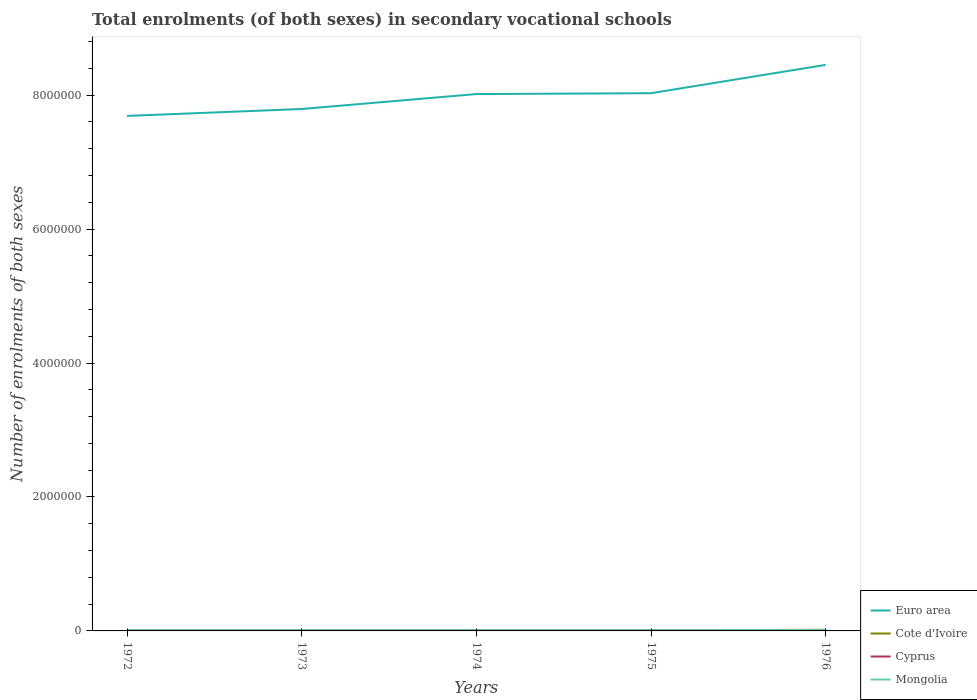Across all years, what is the maximum number of enrolments in secondary schools in Euro area?
Make the answer very short. 7.69e+06. In which year was the number of enrolments in secondary schools in Cyprus maximum?
Give a very brief answer. 1973. What is the total number of enrolments in secondary schools in Euro area in the graph?
Your answer should be very brief. -6.59e+05. What is the difference between the highest and the second highest number of enrolments in secondary schools in Cyprus?
Your answer should be compact. 1914. What is the difference between the highest and the lowest number of enrolments in secondary schools in Euro area?
Give a very brief answer. 3. What is the difference between two consecutive major ticks on the Y-axis?
Your response must be concise. 2.00e+06. Does the graph contain grids?
Your response must be concise. No. Where does the legend appear in the graph?
Your answer should be compact. Bottom right. How many legend labels are there?
Keep it short and to the point. 4. How are the legend labels stacked?
Offer a very short reply. Vertical. What is the title of the graph?
Your response must be concise. Total enrolments (of both sexes) in secondary vocational schools. What is the label or title of the X-axis?
Keep it short and to the point. Years. What is the label or title of the Y-axis?
Make the answer very short. Number of enrolments of both sexes. What is the Number of enrolments of both sexes in Euro area in 1972?
Provide a short and direct response. 7.69e+06. What is the Number of enrolments of both sexes of Cote d'Ivoire in 1972?
Your answer should be very brief. 7297. What is the Number of enrolments of both sexes of Cyprus in 1972?
Provide a succinct answer. 4702. What is the Number of enrolments of both sexes in Mongolia in 1972?
Your answer should be compact. 1.13e+04. What is the Number of enrolments of both sexes of Euro area in 1973?
Ensure brevity in your answer.  7.79e+06. What is the Number of enrolments of both sexes of Cote d'Ivoire in 1973?
Ensure brevity in your answer.  8645. What is the Number of enrolments of both sexes of Cyprus in 1973?
Provide a succinct answer. 4198. What is the Number of enrolments of both sexes of Mongolia in 1973?
Give a very brief answer. 1.15e+04. What is the Number of enrolments of both sexes of Euro area in 1974?
Provide a succinct answer. 8.02e+06. What is the Number of enrolments of both sexes in Cote d'Ivoire in 1974?
Give a very brief answer. 7729. What is the Number of enrolments of both sexes of Cyprus in 1974?
Provide a short and direct response. 4672. What is the Number of enrolments of both sexes in Mongolia in 1974?
Keep it short and to the point. 1.16e+04. What is the Number of enrolments of both sexes in Euro area in 1975?
Provide a short and direct response. 8.03e+06. What is the Number of enrolments of both sexes in Cote d'Ivoire in 1975?
Ensure brevity in your answer.  9253. What is the Number of enrolments of both sexes of Cyprus in 1975?
Provide a succinct answer. 5763. What is the Number of enrolments of both sexes in Mongolia in 1975?
Provide a succinct answer. 1.18e+04. What is the Number of enrolments of both sexes in Euro area in 1976?
Offer a terse response. 8.45e+06. What is the Number of enrolments of both sexes in Cote d'Ivoire in 1976?
Provide a short and direct response. 1.71e+04. What is the Number of enrolments of both sexes of Cyprus in 1976?
Your answer should be compact. 6112. What is the Number of enrolments of both sexes of Mongolia in 1976?
Your answer should be very brief. 1.26e+04. Across all years, what is the maximum Number of enrolments of both sexes of Euro area?
Provide a succinct answer. 8.45e+06. Across all years, what is the maximum Number of enrolments of both sexes in Cote d'Ivoire?
Offer a terse response. 1.71e+04. Across all years, what is the maximum Number of enrolments of both sexes of Cyprus?
Offer a very short reply. 6112. Across all years, what is the maximum Number of enrolments of both sexes in Mongolia?
Give a very brief answer. 1.26e+04. Across all years, what is the minimum Number of enrolments of both sexes of Euro area?
Your answer should be very brief. 7.69e+06. Across all years, what is the minimum Number of enrolments of both sexes in Cote d'Ivoire?
Provide a short and direct response. 7297. Across all years, what is the minimum Number of enrolments of both sexes of Cyprus?
Provide a succinct answer. 4198. Across all years, what is the minimum Number of enrolments of both sexes of Mongolia?
Make the answer very short. 1.13e+04. What is the total Number of enrolments of both sexes in Euro area in the graph?
Give a very brief answer. 4.00e+07. What is the total Number of enrolments of both sexes of Cote d'Ivoire in the graph?
Provide a short and direct response. 5.00e+04. What is the total Number of enrolments of both sexes in Cyprus in the graph?
Offer a very short reply. 2.54e+04. What is the total Number of enrolments of both sexes of Mongolia in the graph?
Your response must be concise. 5.87e+04. What is the difference between the Number of enrolments of both sexes in Euro area in 1972 and that in 1973?
Offer a very short reply. -1.03e+05. What is the difference between the Number of enrolments of both sexes of Cote d'Ivoire in 1972 and that in 1973?
Make the answer very short. -1348. What is the difference between the Number of enrolments of both sexes in Cyprus in 1972 and that in 1973?
Offer a terse response. 504. What is the difference between the Number of enrolments of both sexes of Mongolia in 1972 and that in 1973?
Make the answer very short. -238. What is the difference between the Number of enrolments of both sexes of Euro area in 1972 and that in 1974?
Keep it short and to the point. -3.26e+05. What is the difference between the Number of enrolments of both sexes in Cote d'Ivoire in 1972 and that in 1974?
Provide a succinct answer. -432. What is the difference between the Number of enrolments of both sexes of Cyprus in 1972 and that in 1974?
Offer a terse response. 30. What is the difference between the Number of enrolments of both sexes in Mongolia in 1972 and that in 1974?
Give a very brief answer. -347. What is the difference between the Number of enrolments of both sexes in Euro area in 1972 and that in 1975?
Make the answer very short. -3.39e+05. What is the difference between the Number of enrolments of both sexes of Cote d'Ivoire in 1972 and that in 1975?
Your response must be concise. -1956. What is the difference between the Number of enrolments of both sexes of Cyprus in 1972 and that in 1975?
Your response must be concise. -1061. What is the difference between the Number of enrolments of both sexes of Mongolia in 1972 and that in 1975?
Provide a succinct answer. -535. What is the difference between the Number of enrolments of both sexes of Euro area in 1972 and that in 1976?
Keep it short and to the point. -7.62e+05. What is the difference between the Number of enrolments of both sexes of Cote d'Ivoire in 1972 and that in 1976?
Your response must be concise. -9798. What is the difference between the Number of enrolments of both sexes of Cyprus in 1972 and that in 1976?
Provide a succinct answer. -1410. What is the difference between the Number of enrolments of both sexes in Mongolia in 1972 and that in 1976?
Provide a succinct answer. -1287. What is the difference between the Number of enrolments of both sexes of Euro area in 1973 and that in 1974?
Make the answer very short. -2.23e+05. What is the difference between the Number of enrolments of both sexes of Cote d'Ivoire in 1973 and that in 1974?
Give a very brief answer. 916. What is the difference between the Number of enrolments of both sexes in Cyprus in 1973 and that in 1974?
Provide a short and direct response. -474. What is the difference between the Number of enrolments of both sexes in Mongolia in 1973 and that in 1974?
Ensure brevity in your answer.  -109. What is the difference between the Number of enrolments of both sexes of Euro area in 1973 and that in 1975?
Offer a terse response. -2.36e+05. What is the difference between the Number of enrolments of both sexes in Cote d'Ivoire in 1973 and that in 1975?
Provide a short and direct response. -608. What is the difference between the Number of enrolments of both sexes of Cyprus in 1973 and that in 1975?
Offer a terse response. -1565. What is the difference between the Number of enrolments of both sexes in Mongolia in 1973 and that in 1975?
Keep it short and to the point. -297. What is the difference between the Number of enrolments of both sexes of Euro area in 1973 and that in 1976?
Keep it short and to the point. -6.59e+05. What is the difference between the Number of enrolments of both sexes in Cote d'Ivoire in 1973 and that in 1976?
Ensure brevity in your answer.  -8450. What is the difference between the Number of enrolments of both sexes of Cyprus in 1973 and that in 1976?
Ensure brevity in your answer.  -1914. What is the difference between the Number of enrolments of both sexes in Mongolia in 1973 and that in 1976?
Offer a terse response. -1049. What is the difference between the Number of enrolments of both sexes in Euro area in 1974 and that in 1975?
Ensure brevity in your answer.  -1.26e+04. What is the difference between the Number of enrolments of both sexes in Cote d'Ivoire in 1974 and that in 1975?
Keep it short and to the point. -1524. What is the difference between the Number of enrolments of both sexes of Cyprus in 1974 and that in 1975?
Offer a terse response. -1091. What is the difference between the Number of enrolments of both sexes of Mongolia in 1974 and that in 1975?
Offer a terse response. -188. What is the difference between the Number of enrolments of both sexes of Euro area in 1974 and that in 1976?
Provide a succinct answer. -4.36e+05. What is the difference between the Number of enrolments of both sexes of Cote d'Ivoire in 1974 and that in 1976?
Provide a short and direct response. -9366. What is the difference between the Number of enrolments of both sexes of Cyprus in 1974 and that in 1976?
Provide a short and direct response. -1440. What is the difference between the Number of enrolments of both sexes of Mongolia in 1974 and that in 1976?
Ensure brevity in your answer.  -940. What is the difference between the Number of enrolments of both sexes in Euro area in 1975 and that in 1976?
Ensure brevity in your answer.  -4.23e+05. What is the difference between the Number of enrolments of both sexes of Cote d'Ivoire in 1975 and that in 1976?
Offer a terse response. -7842. What is the difference between the Number of enrolments of both sexes in Cyprus in 1975 and that in 1976?
Give a very brief answer. -349. What is the difference between the Number of enrolments of both sexes in Mongolia in 1975 and that in 1976?
Offer a very short reply. -752. What is the difference between the Number of enrolments of both sexes of Euro area in 1972 and the Number of enrolments of both sexes of Cote d'Ivoire in 1973?
Your answer should be very brief. 7.68e+06. What is the difference between the Number of enrolments of both sexes of Euro area in 1972 and the Number of enrolments of both sexes of Cyprus in 1973?
Provide a short and direct response. 7.69e+06. What is the difference between the Number of enrolments of both sexes in Euro area in 1972 and the Number of enrolments of both sexes in Mongolia in 1973?
Offer a terse response. 7.68e+06. What is the difference between the Number of enrolments of both sexes of Cote d'Ivoire in 1972 and the Number of enrolments of both sexes of Cyprus in 1973?
Your response must be concise. 3099. What is the difference between the Number of enrolments of both sexes in Cote d'Ivoire in 1972 and the Number of enrolments of both sexes in Mongolia in 1973?
Ensure brevity in your answer.  -4208. What is the difference between the Number of enrolments of both sexes in Cyprus in 1972 and the Number of enrolments of both sexes in Mongolia in 1973?
Your answer should be very brief. -6803. What is the difference between the Number of enrolments of both sexes in Euro area in 1972 and the Number of enrolments of both sexes in Cote d'Ivoire in 1974?
Provide a short and direct response. 7.68e+06. What is the difference between the Number of enrolments of both sexes in Euro area in 1972 and the Number of enrolments of both sexes in Cyprus in 1974?
Provide a short and direct response. 7.69e+06. What is the difference between the Number of enrolments of both sexes of Euro area in 1972 and the Number of enrolments of both sexes of Mongolia in 1974?
Your response must be concise. 7.68e+06. What is the difference between the Number of enrolments of both sexes of Cote d'Ivoire in 1972 and the Number of enrolments of both sexes of Cyprus in 1974?
Your answer should be compact. 2625. What is the difference between the Number of enrolments of both sexes in Cote d'Ivoire in 1972 and the Number of enrolments of both sexes in Mongolia in 1974?
Give a very brief answer. -4317. What is the difference between the Number of enrolments of both sexes of Cyprus in 1972 and the Number of enrolments of both sexes of Mongolia in 1974?
Offer a very short reply. -6912. What is the difference between the Number of enrolments of both sexes of Euro area in 1972 and the Number of enrolments of both sexes of Cote d'Ivoire in 1975?
Your response must be concise. 7.68e+06. What is the difference between the Number of enrolments of both sexes in Euro area in 1972 and the Number of enrolments of both sexes in Cyprus in 1975?
Ensure brevity in your answer.  7.68e+06. What is the difference between the Number of enrolments of both sexes in Euro area in 1972 and the Number of enrolments of both sexes in Mongolia in 1975?
Offer a terse response. 7.68e+06. What is the difference between the Number of enrolments of both sexes in Cote d'Ivoire in 1972 and the Number of enrolments of both sexes in Cyprus in 1975?
Make the answer very short. 1534. What is the difference between the Number of enrolments of both sexes in Cote d'Ivoire in 1972 and the Number of enrolments of both sexes in Mongolia in 1975?
Offer a very short reply. -4505. What is the difference between the Number of enrolments of both sexes of Cyprus in 1972 and the Number of enrolments of both sexes of Mongolia in 1975?
Your response must be concise. -7100. What is the difference between the Number of enrolments of both sexes in Euro area in 1972 and the Number of enrolments of both sexes in Cote d'Ivoire in 1976?
Provide a succinct answer. 7.67e+06. What is the difference between the Number of enrolments of both sexes in Euro area in 1972 and the Number of enrolments of both sexes in Cyprus in 1976?
Your answer should be very brief. 7.68e+06. What is the difference between the Number of enrolments of both sexes in Euro area in 1972 and the Number of enrolments of both sexes in Mongolia in 1976?
Your answer should be very brief. 7.68e+06. What is the difference between the Number of enrolments of both sexes in Cote d'Ivoire in 1972 and the Number of enrolments of both sexes in Cyprus in 1976?
Your answer should be compact. 1185. What is the difference between the Number of enrolments of both sexes of Cote d'Ivoire in 1972 and the Number of enrolments of both sexes of Mongolia in 1976?
Your answer should be compact. -5257. What is the difference between the Number of enrolments of both sexes in Cyprus in 1972 and the Number of enrolments of both sexes in Mongolia in 1976?
Your answer should be very brief. -7852. What is the difference between the Number of enrolments of both sexes of Euro area in 1973 and the Number of enrolments of both sexes of Cote d'Ivoire in 1974?
Provide a short and direct response. 7.79e+06. What is the difference between the Number of enrolments of both sexes of Euro area in 1973 and the Number of enrolments of both sexes of Cyprus in 1974?
Provide a short and direct response. 7.79e+06. What is the difference between the Number of enrolments of both sexes of Euro area in 1973 and the Number of enrolments of both sexes of Mongolia in 1974?
Your answer should be very brief. 7.78e+06. What is the difference between the Number of enrolments of both sexes in Cote d'Ivoire in 1973 and the Number of enrolments of both sexes in Cyprus in 1974?
Provide a succinct answer. 3973. What is the difference between the Number of enrolments of both sexes of Cote d'Ivoire in 1973 and the Number of enrolments of both sexes of Mongolia in 1974?
Provide a short and direct response. -2969. What is the difference between the Number of enrolments of both sexes of Cyprus in 1973 and the Number of enrolments of both sexes of Mongolia in 1974?
Make the answer very short. -7416. What is the difference between the Number of enrolments of both sexes in Euro area in 1973 and the Number of enrolments of both sexes in Cote d'Ivoire in 1975?
Offer a terse response. 7.78e+06. What is the difference between the Number of enrolments of both sexes in Euro area in 1973 and the Number of enrolments of both sexes in Cyprus in 1975?
Make the answer very short. 7.79e+06. What is the difference between the Number of enrolments of both sexes in Euro area in 1973 and the Number of enrolments of both sexes in Mongolia in 1975?
Ensure brevity in your answer.  7.78e+06. What is the difference between the Number of enrolments of both sexes of Cote d'Ivoire in 1973 and the Number of enrolments of both sexes of Cyprus in 1975?
Offer a very short reply. 2882. What is the difference between the Number of enrolments of both sexes of Cote d'Ivoire in 1973 and the Number of enrolments of both sexes of Mongolia in 1975?
Offer a terse response. -3157. What is the difference between the Number of enrolments of both sexes of Cyprus in 1973 and the Number of enrolments of both sexes of Mongolia in 1975?
Your answer should be very brief. -7604. What is the difference between the Number of enrolments of both sexes of Euro area in 1973 and the Number of enrolments of both sexes of Cote d'Ivoire in 1976?
Ensure brevity in your answer.  7.78e+06. What is the difference between the Number of enrolments of both sexes in Euro area in 1973 and the Number of enrolments of both sexes in Cyprus in 1976?
Provide a succinct answer. 7.79e+06. What is the difference between the Number of enrolments of both sexes in Euro area in 1973 and the Number of enrolments of both sexes in Mongolia in 1976?
Your answer should be very brief. 7.78e+06. What is the difference between the Number of enrolments of both sexes of Cote d'Ivoire in 1973 and the Number of enrolments of both sexes of Cyprus in 1976?
Your answer should be compact. 2533. What is the difference between the Number of enrolments of both sexes in Cote d'Ivoire in 1973 and the Number of enrolments of both sexes in Mongolia in 1976?
Your answer should be compact. -3909. What is the difference between the Number of enrolments of both sexes of Cyprus in 1973 and the Number of enrolments of both sexes of Mongolia in 1976?
Provide a succinct answer. -8356. What is the difference between the Number of enrolments of both sexes in Euro area in 1974 and the Number of enrolments of both sexes in Cote d'Ivoire in 1975?
Offer a terse response. 8.01e+06. What is the difference between the Number of enrolments of both sexes in Euro area in 1974 and the Number of enrolments of both sexes in Cyprus in 1975?
Provide a short and direct response. 8.01e+06. What is the difference between the Number of enrolments of both sexes of Euro area in 1974 and the Number of enrolments of both sexes of Mongolia in 1975?
Ensure brevity in your answer.  8.00e+06. What is the difference between the Number of enrolments of both sexes of Cote d'Ivoire in 1974 and the Number of enrolments of both sexes of Cyprus in 1975?
Make the answer very short. 1966. What is the difference between the Number of enrolments of both sexes of Cote d'Ivoire in 1974 and the Number of enrolments of both sexes of Mongolia in 1975?
Offer a very short reply. -4073. What is the difference between the Number of enrolments of both sexes in Cyprus in 1974 and the Number of enrolments of both sexes in Mongolia in 1975?
Your answer should be very brief. -7130. What is the difference between the Number of enrolments of both sexes of Euro area in 1974 and the Number of enrolments of both sexes of Cote d'Ivoire in 1976?
Keep it short and to the point. 8.00e+06. What is the difference between the Number of enrolments of both sexes of Euro area in 1974 and the Number of enrolments of both sexes of Cyprus in 1976?
Give a very brief answer. 8.01e+06. What is the difference between the Number of enrolments of both sexes of Euro area in 1974 and the Number of enrolments of both sexes of Mongolia in 1976?
Your response must be concise. 8.00e+06. What is the difference between the Number of enrolments of both sexes of Cote d'Ivoire in 1974 and the Number of enrolments of both sexes of Cyprus in 1976?
Make the answer very short. 1617. What is the difference between the Number of enrolments of both sexes in Cote d'Ivoire in 1974 and the Number of enrolments of both sexes in Mongolia in 1976?
Offer a terse response. -4825. What is the difference between the Number of enrolments of both sexes in Cyprus in 1974 and the Number of enrolments of both sexes in Mongolia in 1976?
Give a very brief answer. -7882. What is the difference between the Number of enrolments of both sexes of Euro area in 1975 and the Number of enrolments of both sexes of Cote d'Ivoire in 1976?
Give a very brief answer. 8.01e+06. What is the difference between the Number of enrolments of both sexes of Euro area in 1975 and the Number of enrolments of both sexes of Cyprus in 1976?
Offer a very short reply. 8.02e+06. What is the difference between the Number of enrolments of both sexes in Euro area in 1975 and the Number of enrolments of both sexes in Mongolia in 1976?
Offer a very short reply. 8.02e+06. What is the difference between the Number of enrolments of both sexes in Cote d'Ivoire in 1975 and the Number of enrolments of both sexes in Cyprus in 1976?
Give a very brief answer. 3141. What is the difference between the Number of enrolments of both sexes of Cote d'Ivoire in 1975 and the Number of enrolments of both sexes of Mongolia in 1976?
Provide a succinct answer. -3301. What is the difference between the Number of enrolments of both sexes in Cyprus in 1975 and the Number of enrolments of both sexes in Mongolia in 1976?
Offer a very short reply. -6791. What is the average Number of enrolments of both sexes in Euro area per year?
Offer a terse response. 8.00e+06. What is the average Number of enrolments of both sexes in Cote d'Ivoire per year?
Your response must be concise. 1.00e+04. What is the average Number of enrolments of both sexes of Cyprus per year?
Your response must be concise. 5089.4. What is the average Number of enrolments of both sexes of Mongolia per year?
Give a very brief answer. 1.17e+04. In the year 1972, what is the difference between the Number of enrolments of both sexes of Euro area and Number of enrolments of both sexes of Cote d'Ivoire?
Your answer should be very brief. 7.68e+06. In the year 1972, what is the difference between the Number of enrolments of both sexes of Euro area and Number of enrolments of both sexes of Cyprus?
Ensure brevity in your answer.  7.69e+06. In the year 1972, what is the difference between the Number of enrolments of both sexes of Euro area and Number of enrolments of both sexes of Mongolia?
Your answer should be very brief. 7.68e+06. In the year 1972, what is the difference between the Number of enrolments of both sexes of Cote d'Ivoire and Number of enrolments of both sexes of Cyprus?
Your answer should be compact. 2595. In the year 1972, what is the difference between the Number of enrolments of both sexes of Cote d'Ivoire and Number of enrolments of both sexes of Mongolia?
Your answer should be very brief. -3970. In the year 1972, what is the difference between the Number of enrolments of both sexes of Cyprus and Number of enrolments of both sexes of Mongolia?
Give a very brief answer. -6565. In the year 1973, what is the difference between the Number of enrolments of both sexes of Euro area and Number of enrolments of both sexes of Cote d'Ivoire?
Your answer should be compact. 7.78e+06. In the year 1973, what is the difference between the Number of enrolments of both sexes in Euro area and Number of enrolments of both sexes in Cyprus?
Give a very brief answer. 7.79e+06. In the year 1973, what is the difference between the Number of enrolments of both sexes of Euro area and Number of enrolments of both sexes of Mongolia?
Offer a terse response. 7.78e+06. In the year 1973, what is the difference between the Number of enrolments of both sexes of Cote d'Ivoire and Number of enrolments of both sexes of Cyprus?
Your answer should be compact. 4447. In the year 1973, what is the difference between the Number of enrolments of both sexes in Cote d'Ivoire and Number of enrolments of both sexes in Mongolia?
Offer a very short reply. -2860. In the year 1973, what is the difference between the Number of enrolments of both sexes of Cyprus and Number of enrolments of both sexes of Mongolia?
Your answer should be very brief. -7307. In the year 1974, what is the difference between the Number of enrolments of both sexes in Euro area and Number of enrolments of both sexes in Cote d'Ivoire?
Ensure brevity in your answer.  8.01e+06. In the year 1974, what is the difference between the Number of enrolments of both sexes in Euro area and Number of enrolments of both sexes in Cyprus?
Give a very brief answer. 8.01e+06. In the year 1974, what is the difference between the Number of enrolments of both sexes of Euro area and Number of enrolments of both sexes of Mongolia?
Your response must be concise. 8.00e+06. In the year 1974, what is the difference between the Number of enrolments of both sexes in Cote d'Ivoire and Number of enrolments of both sexes in Cyprus?
Your answer should be very brief. 3057. In the year 1974, what is the difference between the Number of enrolments of both sexes in Cote d'Ivoire and Number of enrolments of both sexes in Mongolia?
Offer a very short reply. -3885. In the year 1974, what is the difference between the Number of enrolments of both sexes in Cyprus and Number of enrolments of both sexes in Mongolia?
Make the answer very short. -6942. In the year 1975, what is the difference between the Number of enrolments of both sexes in Euro area and Number of enrolments of both sexes in Cote d'Ivoire?
Provide a succinct answer. 8.02e+06. In the year 1975, what is the difference between the Number of enrolments of both sexes of Euro area and Number of enrolments of both sexes of Cyprus?
Keep it short and to the point. 8.02e+06. In the year 1975, what is the difference between the Number of enrolments of both sexes in Euro area and Number of enrolments of both sexes in Mongolia?
Offer a terse response. 8.02e+06. In the year 1975, what is the difference between the Number of enrolments of both sexes of Cote d'Ivoire and Number of enrolments of both sexes of Cyprus?
Give a very brief answer. 3490. In the year 1975, what is the difference between the Number of enrolments of both sexes of Cote d'Ivoire and Number of enrolments of both sexes of Mongolia?
Offer a very short reply. -2549. In the year 1975, what is the difference between the Number of enrolments of both sexes of Cyprus and Number of enrolments of both sexes of Mongolia?
Keep it short and to the point. -6039. In the year 1976, what is the difference between the Number of enrolments of both sexes of Euro area and Number of enrolments of both sexes of Cote d'Ivoire?
Provide a short and direct response. 8.44e+06. In the year 1976, what is the difference between the Number of enrolments of both sexes in Euro area and Number of enrolments of both sexes in Cyprus?
Offer a terse response. 8.45e+06. In the year 1976, what is the difference between the Number of enrolments of both sexes in Euro area and Number of enrolments of both sexes in Mongolia?
Your answer should be compact. 8.44e+06. In the year 1976, what is the difference between the Number of enrolments of both sexes in Cote d'Ivoire and Number of enrolments of both sexes in Cyprus?
Make the answer very short. 1.10e+04. In the year 1976, what is the difference between the Number of enrolments of both sexes of Cote d'Ivoire and Number of enrolments of both sexes of Mongolia?
Keep it short and to the point. 4541. In the year 1976, what is the difference between the Number of enrolments of both sexes of Cyprus and Number of enrolments of both sexes of Mongolia?
Provide a short and direct response. -6442. What is the ratio of the Number of enrolments of both sexes in Euro area in 1972 to that in 1973?
Offer a very short reply. 0.99. What is the ratio of the Number of enrolments of both sexes in Cote d'Ivoire in 1972 to that in 1973?
Keep it short and to the point. 0.84. What is the ratio of the Number of enrolments of both sexes of Cyprus in 1972 to that in 1973?
Ensure brevity in your answer.  1.12. What is the ratio of the Number of enrolments of both sexes in Mongolia in 1972 to that in 1973?
Your answer should be very brief. 0.98. What is the ratio of the Number of enrolments of both sexes in Euro area in 1972 to that in 1974?
Keep it short and to the point. 0.96. What is the ratio of the Number of enrolments of both sexes in Cote d'Ivoire in 1972 to that in 1974?
Provide a succinct answer. 0.94. What is the ratio of the Number of enrolments of both sexes of Cyprus in 1972 to that in 1974?
Your answer should be very brief. 1.01. What is the ratio of the Number of enrolments of both sexes in Mongolia in 1972 to that in 1974?
Offer a terse response. 0.97. What is the ratio of the Number of enrolments of both sexes of Euro area in 1972 to that in 1975?
Your answer should be very brief. 0.96. What is the ratio of the Number of enrolments of both sexes of Cote d'Ivoire in 1972 to that in 1975?
Your answer should be compact. 0.79. What is the ratio of the Number of enrolments of both sexes in Cyprus in 1972 to that in 1975?
Your response must be concise. 0.82. What is the ratio of the Number of enrolments of both sexes of Mongolia in 1972 to that in 1975?
Your answer should be compact. 0.95. What is the ratio of the Number of enrolments of both sexes of Euro area in 1972 to that in 1976?
Ensure brevity in your answer.  0.91. What is the ratio of the Number of enrolments of both sexes of Cote d'Ivoire in 1972 to that in 1976?
Give a very brief answer. 0.43. What is the ratio of the Number of enrolments of both sexes of Cyprus in 1972 to that in 1976?
Your answer should be compact. 0.77. What is the ratio of the Number of enrolments of both sexes of Mongolia in 1972 to that in 1976?
Keep it short and to the point. 0.9. What is the ratio of the Number of enrolments of both sexes of Euro area in 1973 to that in 1974?
Your answer should be compact. 0.97. What is the ratio of the Number of enrolments of both sexes of Cote d'Ivoire in 1973 to that in 1974?
Give a very brief answer. 1.12. What is the ratio of the Number of enrolments of both sexes of Cyprus in 1973 to that in 1974?
Offer a very short reply. 0.9. What is the ratio of the Number of enrolments of both sexes of Mongolia in 1973 to that in 1974?
Your answer should be compact. 0.99. What is the ratio of the Number of enrolments of both sexes in Euro area in 1973 to that in 1975?
Provide a succinct answer. 0.97. What is the ratio of the Number of enrolments of both sexes in Cote d'Ivoire in 1973 to that in 1975?
Keep it short and to the point. 0.93. What is the ratio of the Number of enrolments of both sexes of Cyprus in 1973 to that in 1975?
Ensure brevity in your answer.  0.73. What is the ratio of the Number of enrolments of both sexes in Mongolia in 1973 to that in 1975?
Your answer should be compact. 0.97. What is the ratio of the Number of enrolments of both sexes in Euro area in 1973 to that in 1976?
Provide a succinct answer. 0.92. What is the ratio of the Number of enrolments of both sexes of Cote d'Ivoire in 1973 to that in 1976?
Ensure brevity in your answer.  0.51. What is the ratio of the Number of enrolments of both sexes in Cyprus in 1973 to that in 1976?
Provide a short and direct response. 0.69. What is the ratio of the Number of enrolments of both sexes of Mongolia in 1973 to that in 1976?
Keep it short and to the point. 0.92. What is the ratio of the Number of enrolments of both sexes of Cote d'Ivoire in 1974 to that in 1975?
Make the answer very short. 0.84. What is the ratio of the Number of enrolments of both sexes of Cyprus in 1974 to that in 1975?
Give a very brief answer. 0.81. What is the ratio of the Number of enrolments of both sexes of Mongolia in 1974 to that in 1975?
Offer a very short reply. 0.98. What is the ratio of the Number of enrolments of both sexes of Euro area in 1974 to that in 1976?
Provide a short and direct response. 0.95. What is the ratio of the Number of enrolments of both sexes in Cote d'Ivoire in 1974 to that in 1976?
Your answer should be very brief. 0.45. What is the ratio of the Number of enrolments of both sexes in Cyprus in 1974 to that in 1976?
Your answer should be compact. 0.76. What is the ratio of the Number of enrolments of both sexes in Mongolia in 1974 to that in 1976?
Your response must be concise. 0.93. What is the ratio of the Number of enrolments of both sexes in Euro area in 1975 to that in 1976?
Make the answer very short. 0.95. What is the ratio of the Number of enrolments of both sexes in Cote d'Ivoire in 1975 to that in 1976?
Keep it short and to the point. 0.54. What is the ratio of the Number of enrolments of both sexes in Cyprus in 1975 to that in 1976?
Your answer should be very brief. 0.94. What is the ratio of the Number of enrolments of both sexes of Mongolia in 1975 to that in 1976?
Offer a very short reply. 0.94. What is the difference between the highest and the second highest Number of enrolments of both sexes in Euro area?
Your answer should be compact. 4.23e+05. What is the difference between the highest and the second highest Number of enrolments of both sexes in Cote d'Ivoire?
Provide a short and direct response. 7842. What is the difference between the highest and the second highest Number of enrolments of both sexes of Cyprus?
Provide a succinct answer. 349. What is the difference between the highest and the second highest Number of enrolments of both sexes of Mongolia?
Give a very brief answer. 752. What is the difference between the highest and the lowest Number of enrolments of both sexes in Euro area?
Keep it short and to the point. 7.62e+05. What is the difference between the highest and the lowest Number of enrolments of both sexes in Cote d'Ivoire?
Offer a very short reply. 9798. What is the difference between the highest and the lowest Number of enrolments of both sexes in Cyprus?
Provide a succinct answer. 1914. What is the difference between the highest and the lowest Number of enrolments of both sexes of Mongolia?
Your answer should be very brief. 1287. 